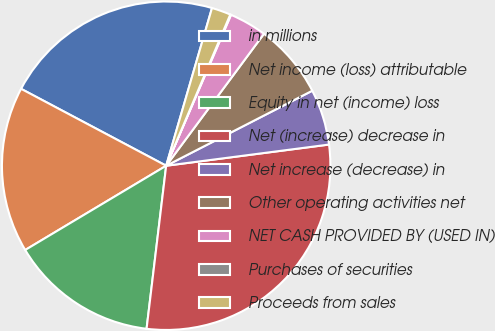Convert chart. <chart><loc_0><loc_0><loc_500><loc_500><pie_chart><fcel>in millions<fcel>Net income (loss) attributable<fcel>Equity in net (income) loss<fcel>Net (increase) decrease in<fcel>Net increase (decrease) in<fcel>Other operating activities net<fcel>NET CASH PROVIDED BY (USED IN)<fcel>Purchases of securities<fcel>Proceeds from sales<nl><fcel>21.74%<fcel>16.33%<fcel>14.52%<fcel>28.96%<fcel>5.49%<fcel>7.3%<fcel>3.69%<fcel>0.08%<fcel>1.88%<nl></chart> 